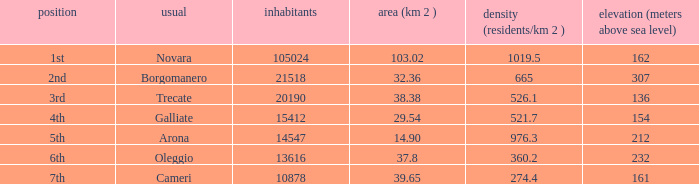Which common has a size (km2) of 3 Trecate. 